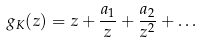<formula> <loc_0><loc_0><loc_500><loc_500>g _ { K } ( z ) = z + \frac { a _ { 1 } } { z } + \frac { a _ { 2 } } { z ^ { 2 } } + \dots</formula> 